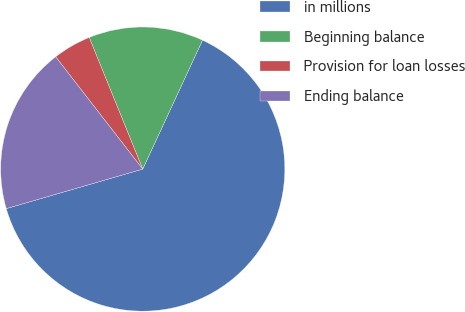Convert chart to OTSL. <chart><loc_0><loc_0><loc_500><loc_500><pie_chart><fcel>in millions<fcel>Beginning balance<fcel>Provision for loan losses<fcel>Ending balance<nl><fcel>63.6%<fcel>13.06%<fcel>4.35%<fcel>18.99%<nl></chart> 